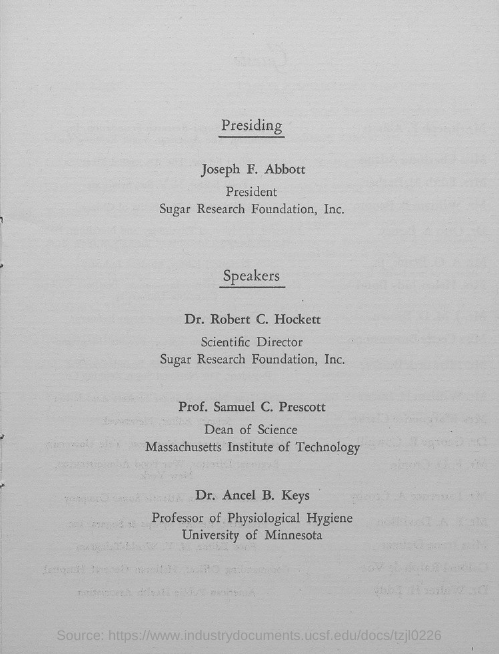Point out several critical features in this image. Dr. Ancel B. Keys works at the University of Minnesota. The president of Sugar Research Foundation, Inc. is Joseph F. Abbott. Dr. Robert C. Hockett is designated as the scientific director. Prof. Samuel C. Prescott holds the designation of Dean of Science. 